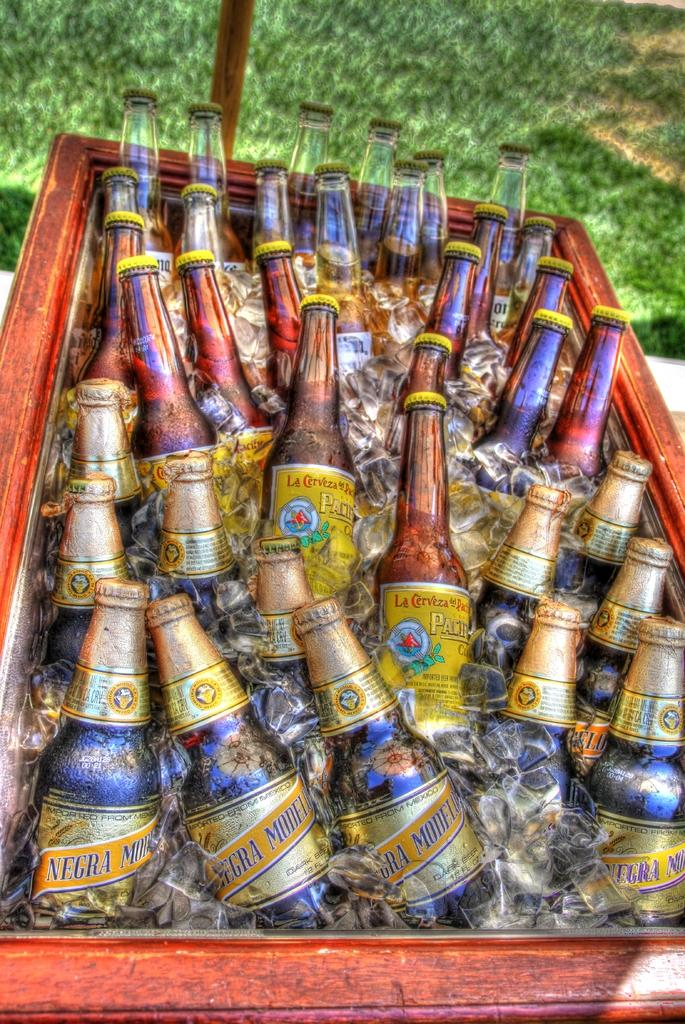<image>
Give a short and clear explanation of the subsequent image. Negra Modelo is one of the beer choices in the container. 